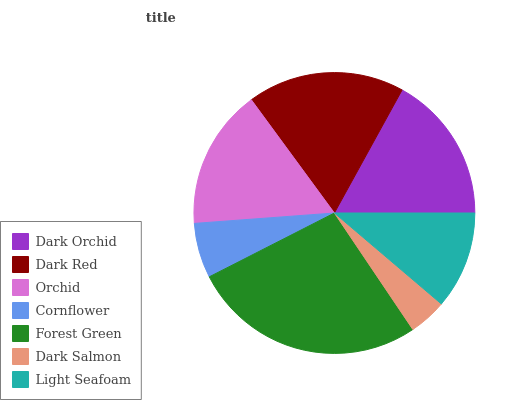Is Dark Salmon the minimum?
Answer yes or no. Yes. Is Forest Green the maximum?
Answer yes or no. Yes. Is Dark Red the minimum?
Answer yes or no. No. Is Dark Red the maximum?
Answer yes or no. No. Is Dark Red greater than Dark Orchid?
Answer yes or no. Yes. Is Dark Orchid less than Dark Red?
Answer yes or no. Yes. Is Dark Orchid greater than Dark Red?
Answer yes or no. No. Is Dark Red less than Dark Orchid?
Answer yes or no. No. Is Orchid the high median?
Answer yes or no. Yes. Is Orchid the low median?
Answer yes or no. Yes. Is Dark Red the high median?
Answer yes or no. No. Is Light Seafoam the low median?
Answer yes or no. No. 